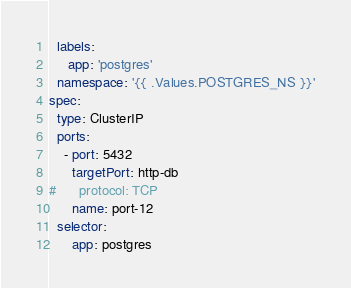<code> <loc_0><loc_0><loc_500><loc_500><_YAML_>  labels:
     app: 'postgres'
  namespace: '{{ .Values.POSTGRES_NS }}'
spec:
  type: ClusterIP
  ports:
    - port: 5432
      targetPort: http-db
#      protocol: TCP
      name: port-12
  selector:
      app: postgres
</code> 